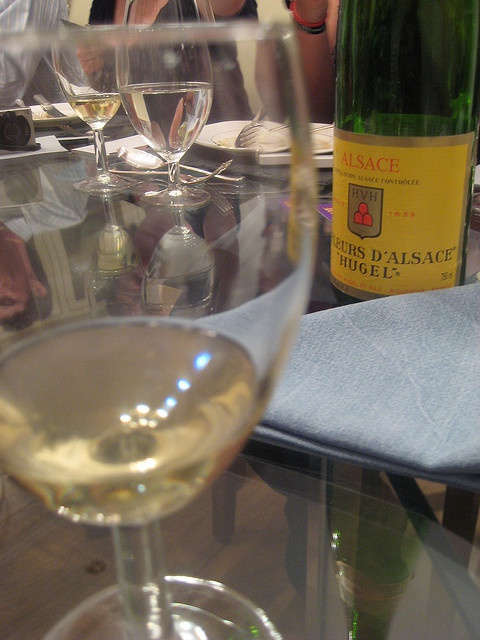Describe the objects in this image and their specific colors. I can see wine glass in lightgray, gray, tan, and darkgray tones, bottle in lightgray, black, and olive tones, people in lightgray and gray tones, people in lightgray, brown, black, tan, and maroon tones, and spoon in lightgray, white, tan, and darkgray tones in this image. 